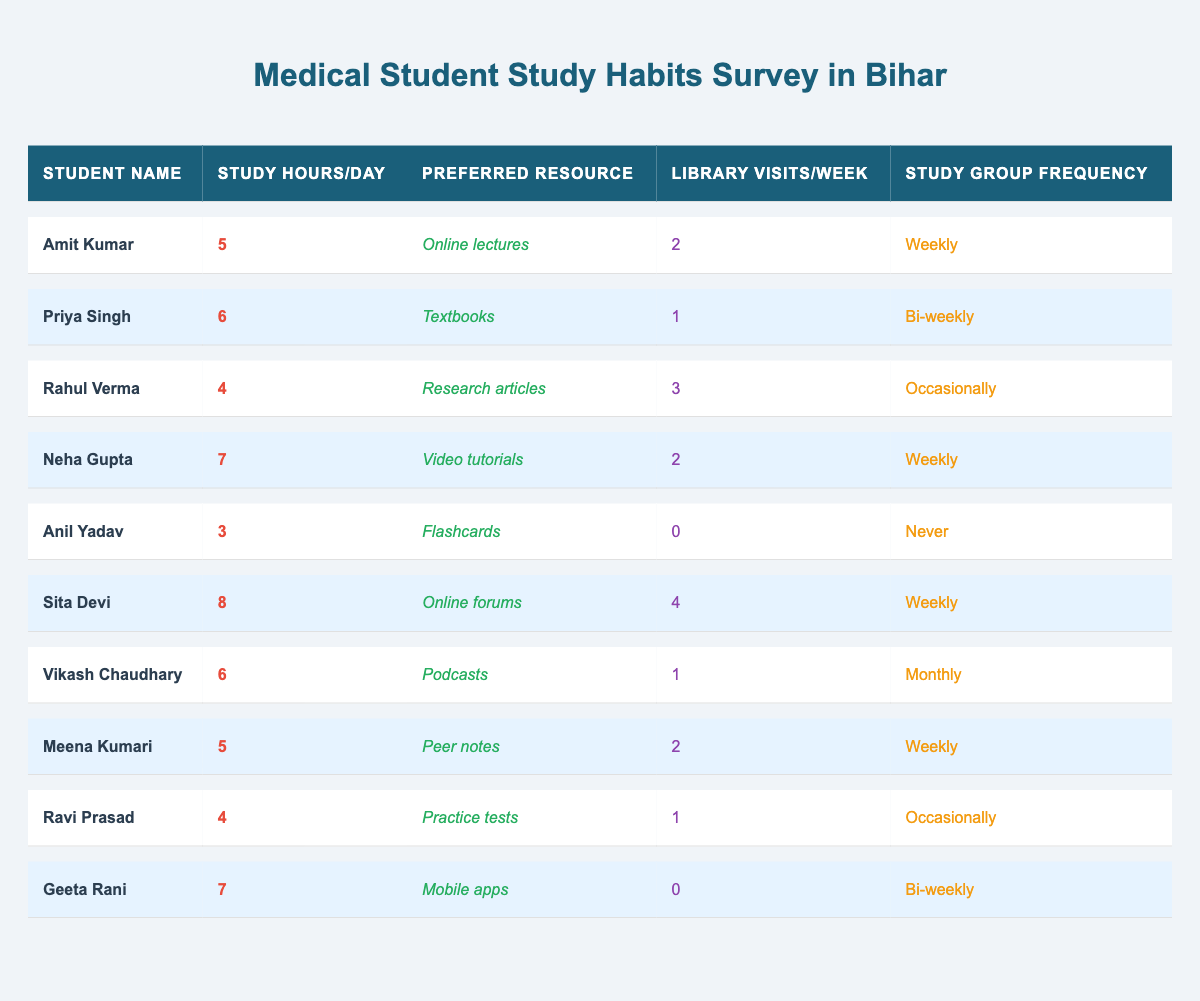What is the preferred resource of Sita Devi? According to the table, Sita Devi's preferred resource is noted as "Online forums."
Answer: Online forums How many study hours per day does Neha Gupta study? The table indicates that Neha Gupta studies for 7 hours per day.
Answer: 7 hours Who visits the library the most per week? By comparing the library visits, Sita Devi visits 4 times, which is the highest among all students.
Answer: Sita Devi What is the average number of library visits per week among the students? To find the average, sum the library visits (2 + 1 + 3 + 2 + 0 + 4 + 1 + 2 + 1 + 0 = 16) and divide by the number of students (10), giving 16/10 = 1.6.
Answer: 1.6 visits Does Anil Yadav utilize the library frequently? Anil Yadav has 0 library visits per week, indicating he does not utilize the library frequently.
Answer: No How many students study 6 hours per day? There are two students, Priya Singh and Vikash Chaudhary, who each study for 6 hours per day.
Answer: 2 students What is the total number of study hours for all students combined? Total study hours can be calculated by summing all the study hours (5 + 6 + 4 + 7 + 3 + 8 + 6 + 5 + 4 + 7 = 55).
Answer: 55 hours Which study group frequency is most common among the students? The most commonly listed study group frequency is "Weekly," shared by Amit Kumar, Neha Gupta, Sita Devi, and Meena Kumari.
Answer: Weekly Is there any student who studies more than 8 hours a day? No student in the table studies more than 8 hours a day, as the maximum is 8 hours by Sita Devi.
Answer: No What is the difference in study hours per day between the highest and lowest studying students? The highest study hours are 8 (Sita Devi) and the lowest is 3 (Anil Yadav). Therefore, the difference is 8 - 3 = 5 hours.
Answer: 5 hours How often does Rahul Verma participate in study groups? Rahul Verma participates in study groups occasionally, as indicated in the table.
Answer: Occasionally 